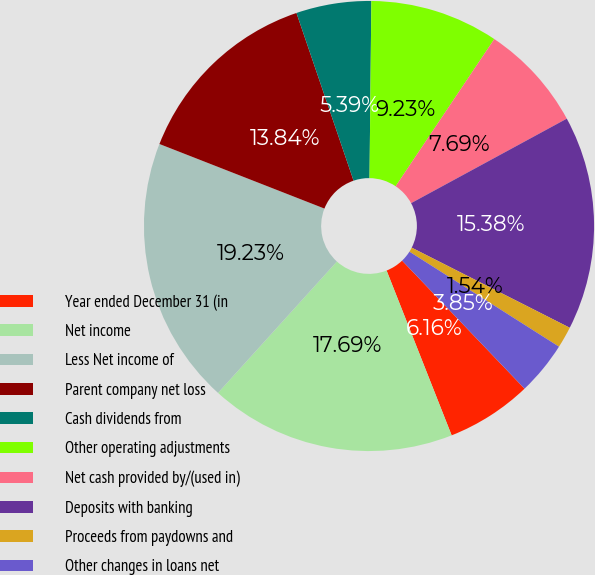Convert chart to OTSL. <chart><loc_0><loc_0><loc_500><loc_500><pie_chart><fcel>Year ended December 31 (in<fcel>Net income<fcel>Less Net income of<fcel>Parent company net loss<fcel>Cash dividends from<fcel>Other operating adjustments<fcel>Net cash provided by/(used in)<fcel>Deposits with banking<fcel>Proceeds from paydowns and<fcel>Other changes in loans net<nl><fcel>6.16%<fcel>17.69%<fcel>19.23%<fcel>13.84%<fcel>5.39%<fcel>9.23%<fcel>7.69%<fcel>15.38%<fcel>1.54%<fcel>3.85%<nl></chart> 